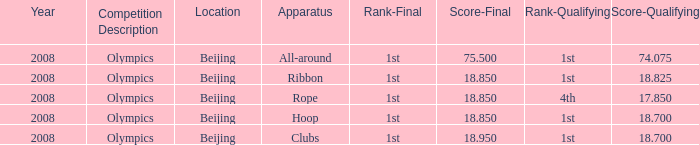On which device did kanayeva obtain a final score less than 7 Rope. 